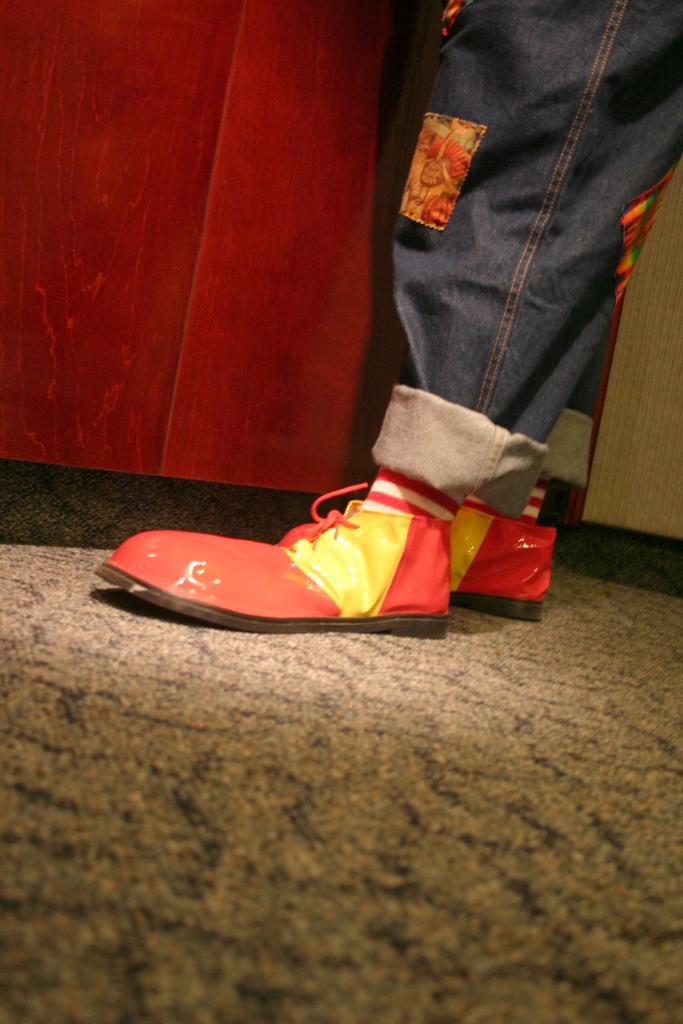What can be seen on the right side of the image? There is a person standing on the right side of the image. What is located at the top left side of the image? There is an object at the top left side of the image. How many cherries are on the shirt of the person in the image? There is no shirt or cherries mentioned in the image, so we cannot determine if there are any cherries on a shirt. 